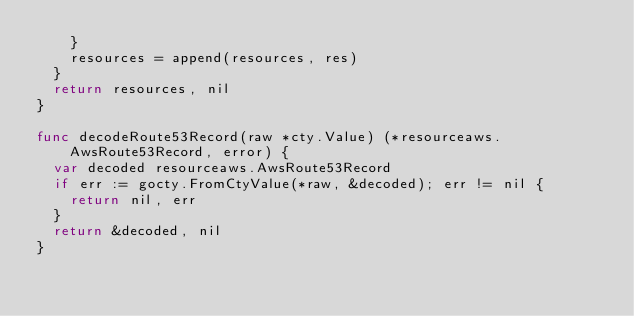<code> <loc_0><loc_0><loc_500><loc_500><_Go_>		}
		resources = append(resources, res)
	}
	return resources, nil
}

func decodeRoute53Record(raw *cty.Value) (*resourceaws.AwsRoute53Record, error) {
	var decoded resourceaws.AwsRoute53Record
	if err := gocty.FromCtyValue(*raw, &decoded); err != nil {
		return nil, err
	}
	return &decoded, nil
}
</code> 